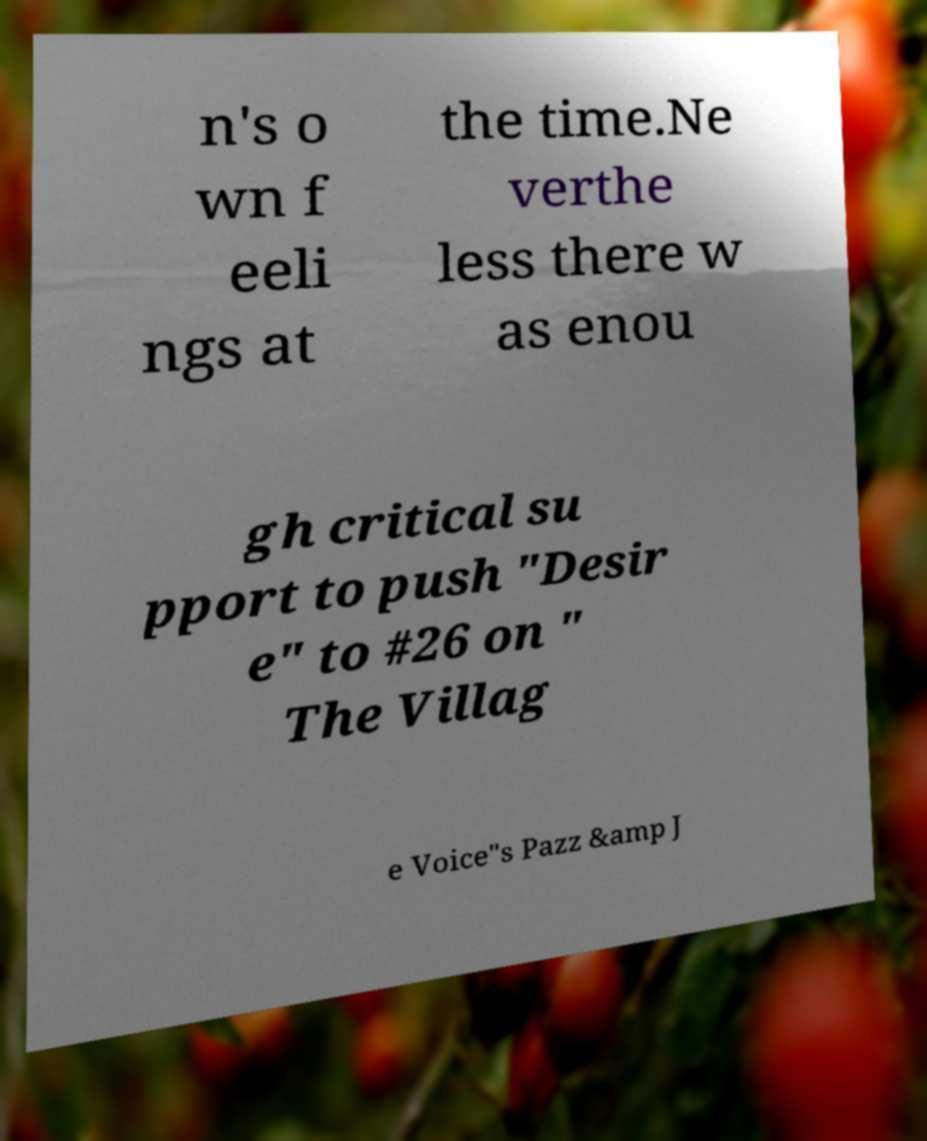Please identify and transcribe the text found in this image. n's o wn f eeli ngs at the time.Ne verthe less there w as enou gh critical su pport to push "Desir e" to #26 on " The Villag e Voice"s Pazz &amp J 